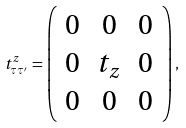Convert formula to latex. <formula><loc_0><loc_0><loc_500><loc_500>t _ { \tau \tau ^ { \prime } } ^ { z } = \left ( \begin{array} { c c c } 0 & 0 & 0 \\ 0 & t _ { z } & 0 \\ 0 & 0 & 0 \\ \end{array} \right ) ,</formula> 